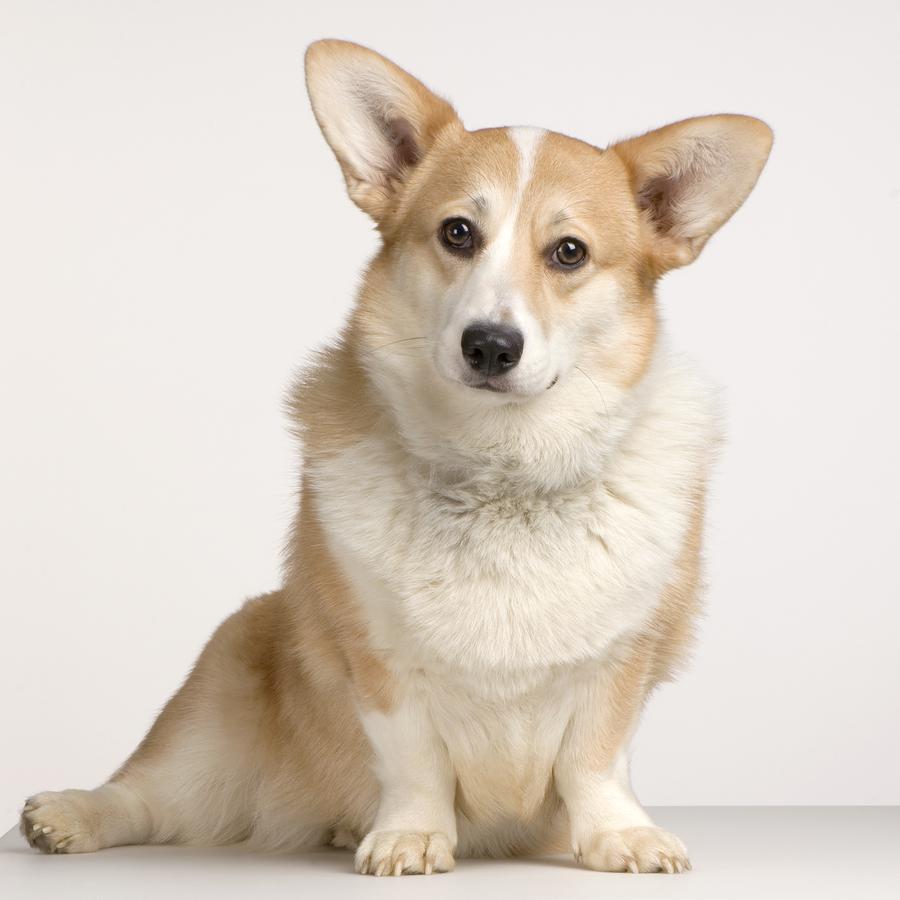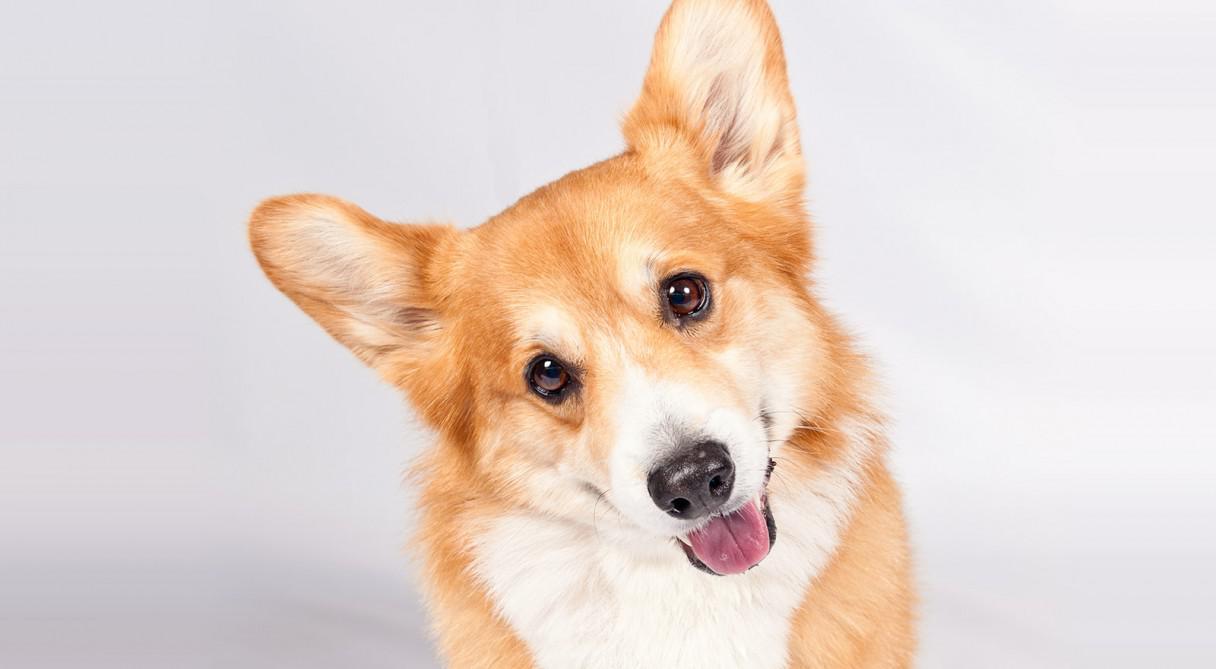The first image is the image on the left, the second image is the image on the right. Analyze the images presented: Is the assertion "All dogs are on a natural surface outside." valid? Answer yes or no. No. 